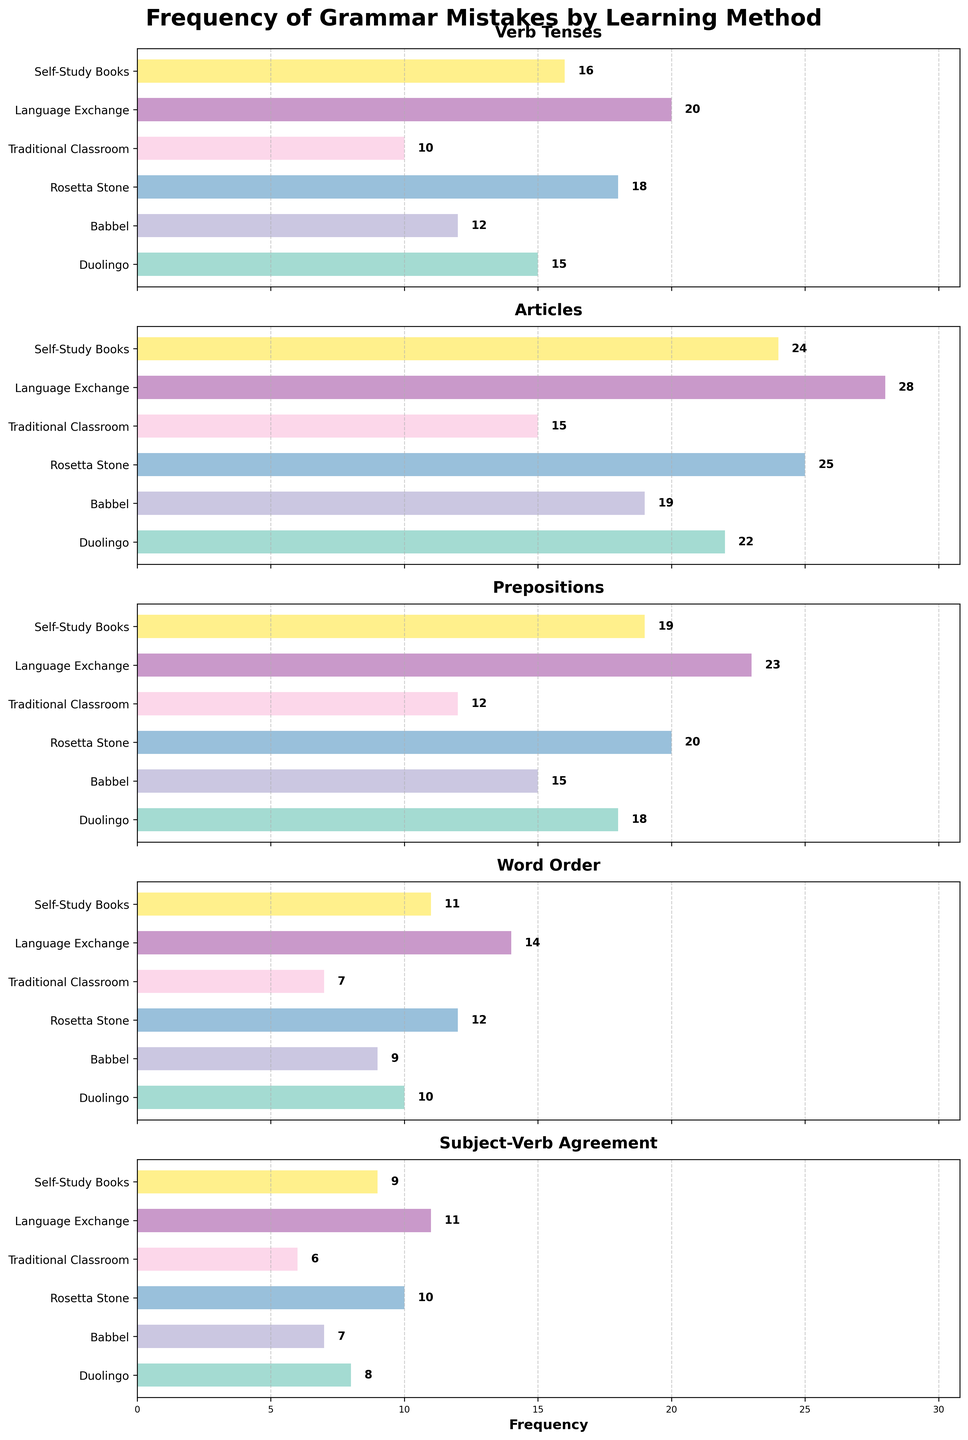what is the title of the figure? The title is located at the top center of the figure and summarizes what the figure is about.
Answer: Frequency of Grammar Mistakes by Learning Method Which method has the highest frequency of verb tenses mistakes? By observing the Verb Tenses subplot, identify the bar with the highest value.
Answer: Language Exchange Which method has the lowest frequency of prepositions mistakes? Look at the Prepositions subplot and find the bar representing the lowest value.
Answer: Traditional Classroom How many more mistakes in articles are made by Rosetta Stone users than Traditional Classroom users? In the Articles subplot, compare the values for Rosetta Stone and Traditional Classroom and subtract the latter from the former: 25 - 15 = 10
Answer: 10 On average, how many mistakes are made in subject-verb agreement across all methods? Sum the values for the Subject-Verb Agreement subplot and divide by the number of methods: (8 + 7 + 10 + 6 + 11 + 9) / 6 = 8.5
Answer: 8.5 Which method has the second highest frequency of word order mistakes? Observe the Word Order subplot and identify the method with the second tallest bar.
Answer: Language Exchange How does the frequency of grammar mistakes in articles for Duolingo compare to Rosetta Stone? Compare the height of the bars for Duolingo and Rosetta Stone users in the Articles subplot. Duolingo is lower than Rosetta Stone by 3 (22 vs 25).
Answer: Duolingo has fewer mistakes Which learning method consistently appears to have the least frequency of mistakes across all categories? By reviewing all subplots, identify which method has the lowest bars most frequently.
Answer: Traditional Classroom What is the total number of mistakes made in verb tenses by all methods combined? Sum the values for the Verb Tenses subplot across all methods: 15 + 12 + 18 + 10 + 20 + 16 = 91
Answer: 91 Is the number of mistakes in prepositions for Language Exchange greater than twice that for Babbel? Calculate twice the number of mistakes for Babbel and compare it to Language Exchange: 2 * 15 = 30, which is greater than Language Exchange's 23.
Answer: No 